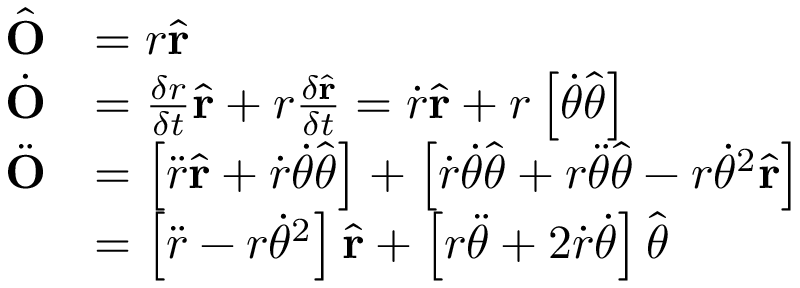<formula> <loc_0><loc_0><loc_500><loc_500>{ \begin{array} { r l } { { \hat { O } } } & { = r { \hat { r } } } \\ { { \dot { O } } } & { = { \frac { \delta r } { \delta t } } { \hat { r } } + r { \frac { \delta { \hat { r } } } { \delta t } } = { \dot { r } } { \hat { r } } + r \left [ { \dot { \theta } } { \hat { \theta } } \right ] } \\ { { \ddot { O } } } & { = \left [ { \ddot { r } } { \hat { r } } + { \dot { r } } { \dot { \theta } } { \hat { \theta } } \right ] + \left [ { \dot { r } } { \dot { \theta } } { \hat { \theta } } + r { \ddot { \theta } } { \hat { \theta } } - r { \dot { \theta } } ^ { 2 } { \hat { r } } \right ] } \\ & { = \left [ { \ddot { r } } - r { \dot { \theta } } ^ { 2 } \right ] { \hat { r } } + \left [ r { \ddot { \theta } } + 2 { \dot { r } } { \dot { \theta } } \right ] { \hat { \theta } } } \end{array} }</formula> 